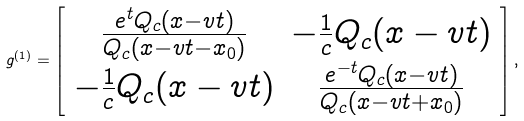<formula> <loc_0><loc_0><loc_500><loc_500>g ^ { ( 1 ) } = \left [ \begin{array} { c c } \frac { e ^ { t } Q _ { c } ( x - v t ) } { Q _ { c } ( x - v t - x _ { 0 } ) } & - \frac { 1 } { c } Q _ { c } ( x - v t ) \\ - \frac { 1 } { c } Q _ { c } ( x - v t ) & \frac { e ^ { - t } Q _ { c } ( x - v t ) } { Q _ { c } ( x - v t + x _ { 0 } ) } \end{array} \right ] ,</formula> 